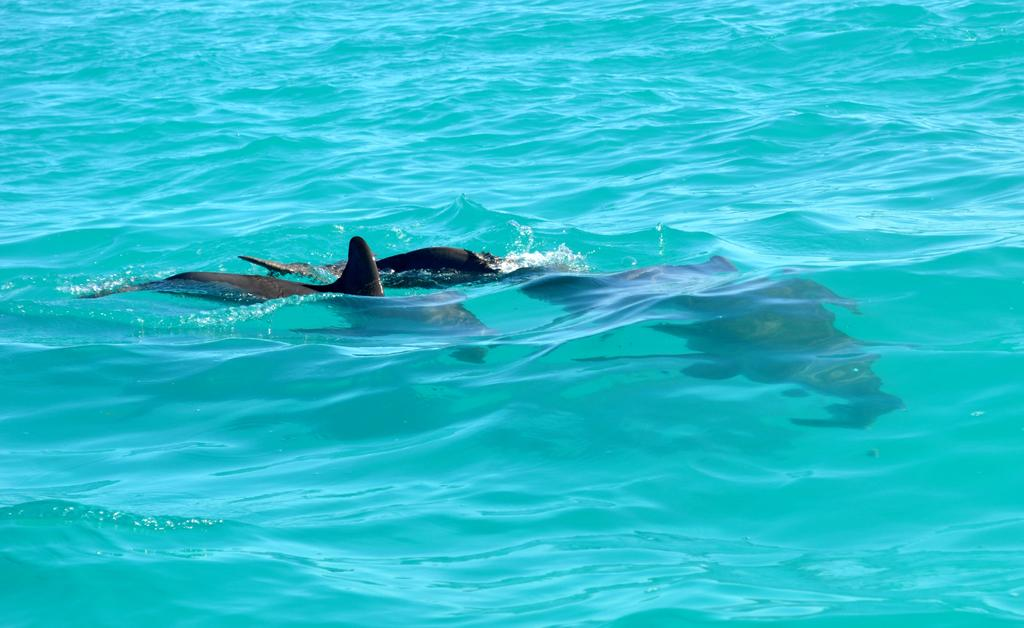What animals can be seen in the image? There are dolphins in the image. Where are the dolphins located? The dolphins are in a water body. How does the servant assist the dolphins in the image? There is no servant present in the image, as it only features dolphins in a water body. 